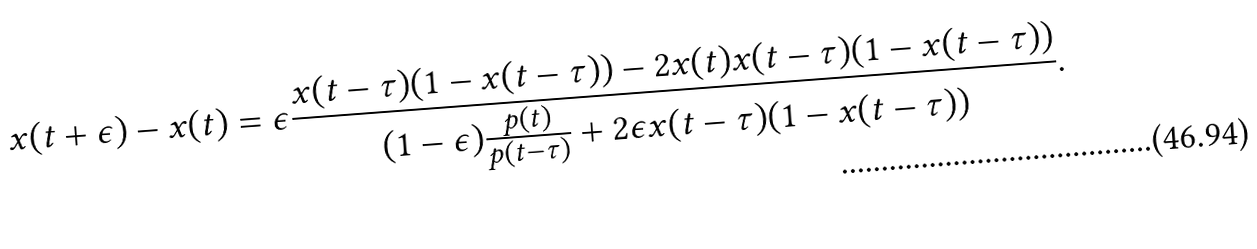Convert formula to latex. <formula><loc_0><loc_0><loc_500><loc_500>x ( t + \epsilon ) - x ( t ) = \epsilon \frac { x ( t - \tau ) ( 1 - x ( t - \tau ) ) - 2 x ( t ) x ( t - \tau ) ( 1 - x ( t - \tau ) ) } { ( 1 - \epsilon ) \frac { p ( t ) } { p ( t - \tau ) } + 2 \epsilon x ( t - \tau ) ( 1 - x ( t - \tau ) ) } .</formula> 